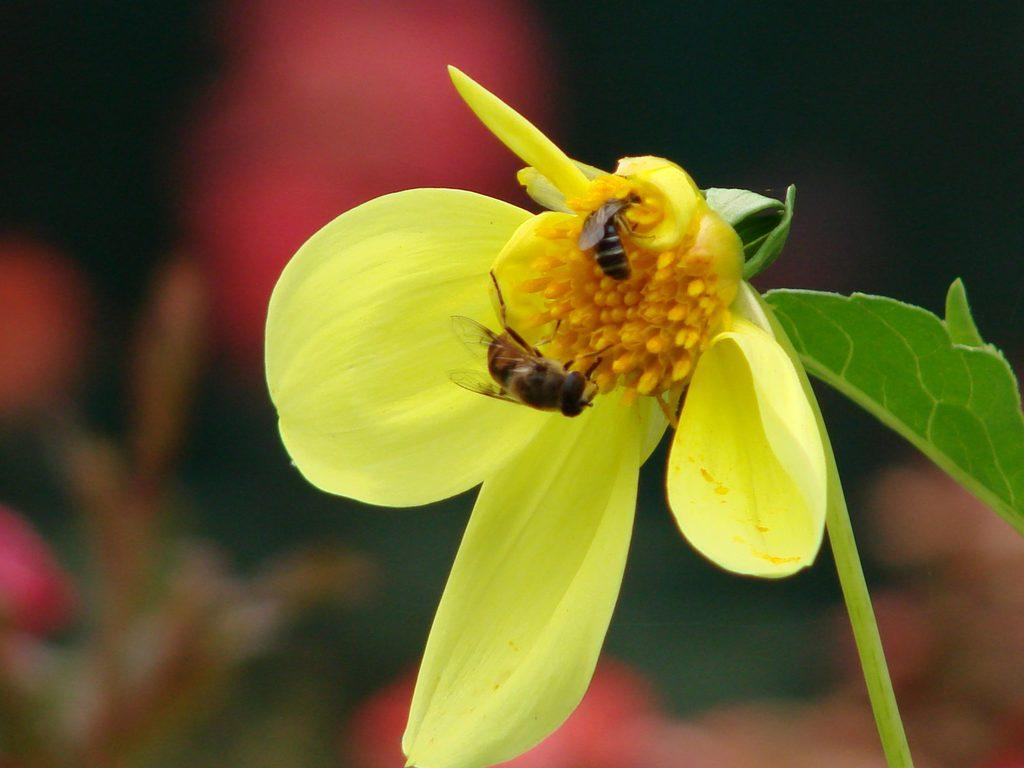What type of insects can be seen in the image? There are honey bees in the image. Where are the honey bees located? The honey bees are on a flower. What type of sponge can be seen in the image? There is no sponge present in the image; it features honey bees on a flower. Can you tell me how many bats are visible in the image? There are no bats visible in the image; it features honey bees on a flower. 